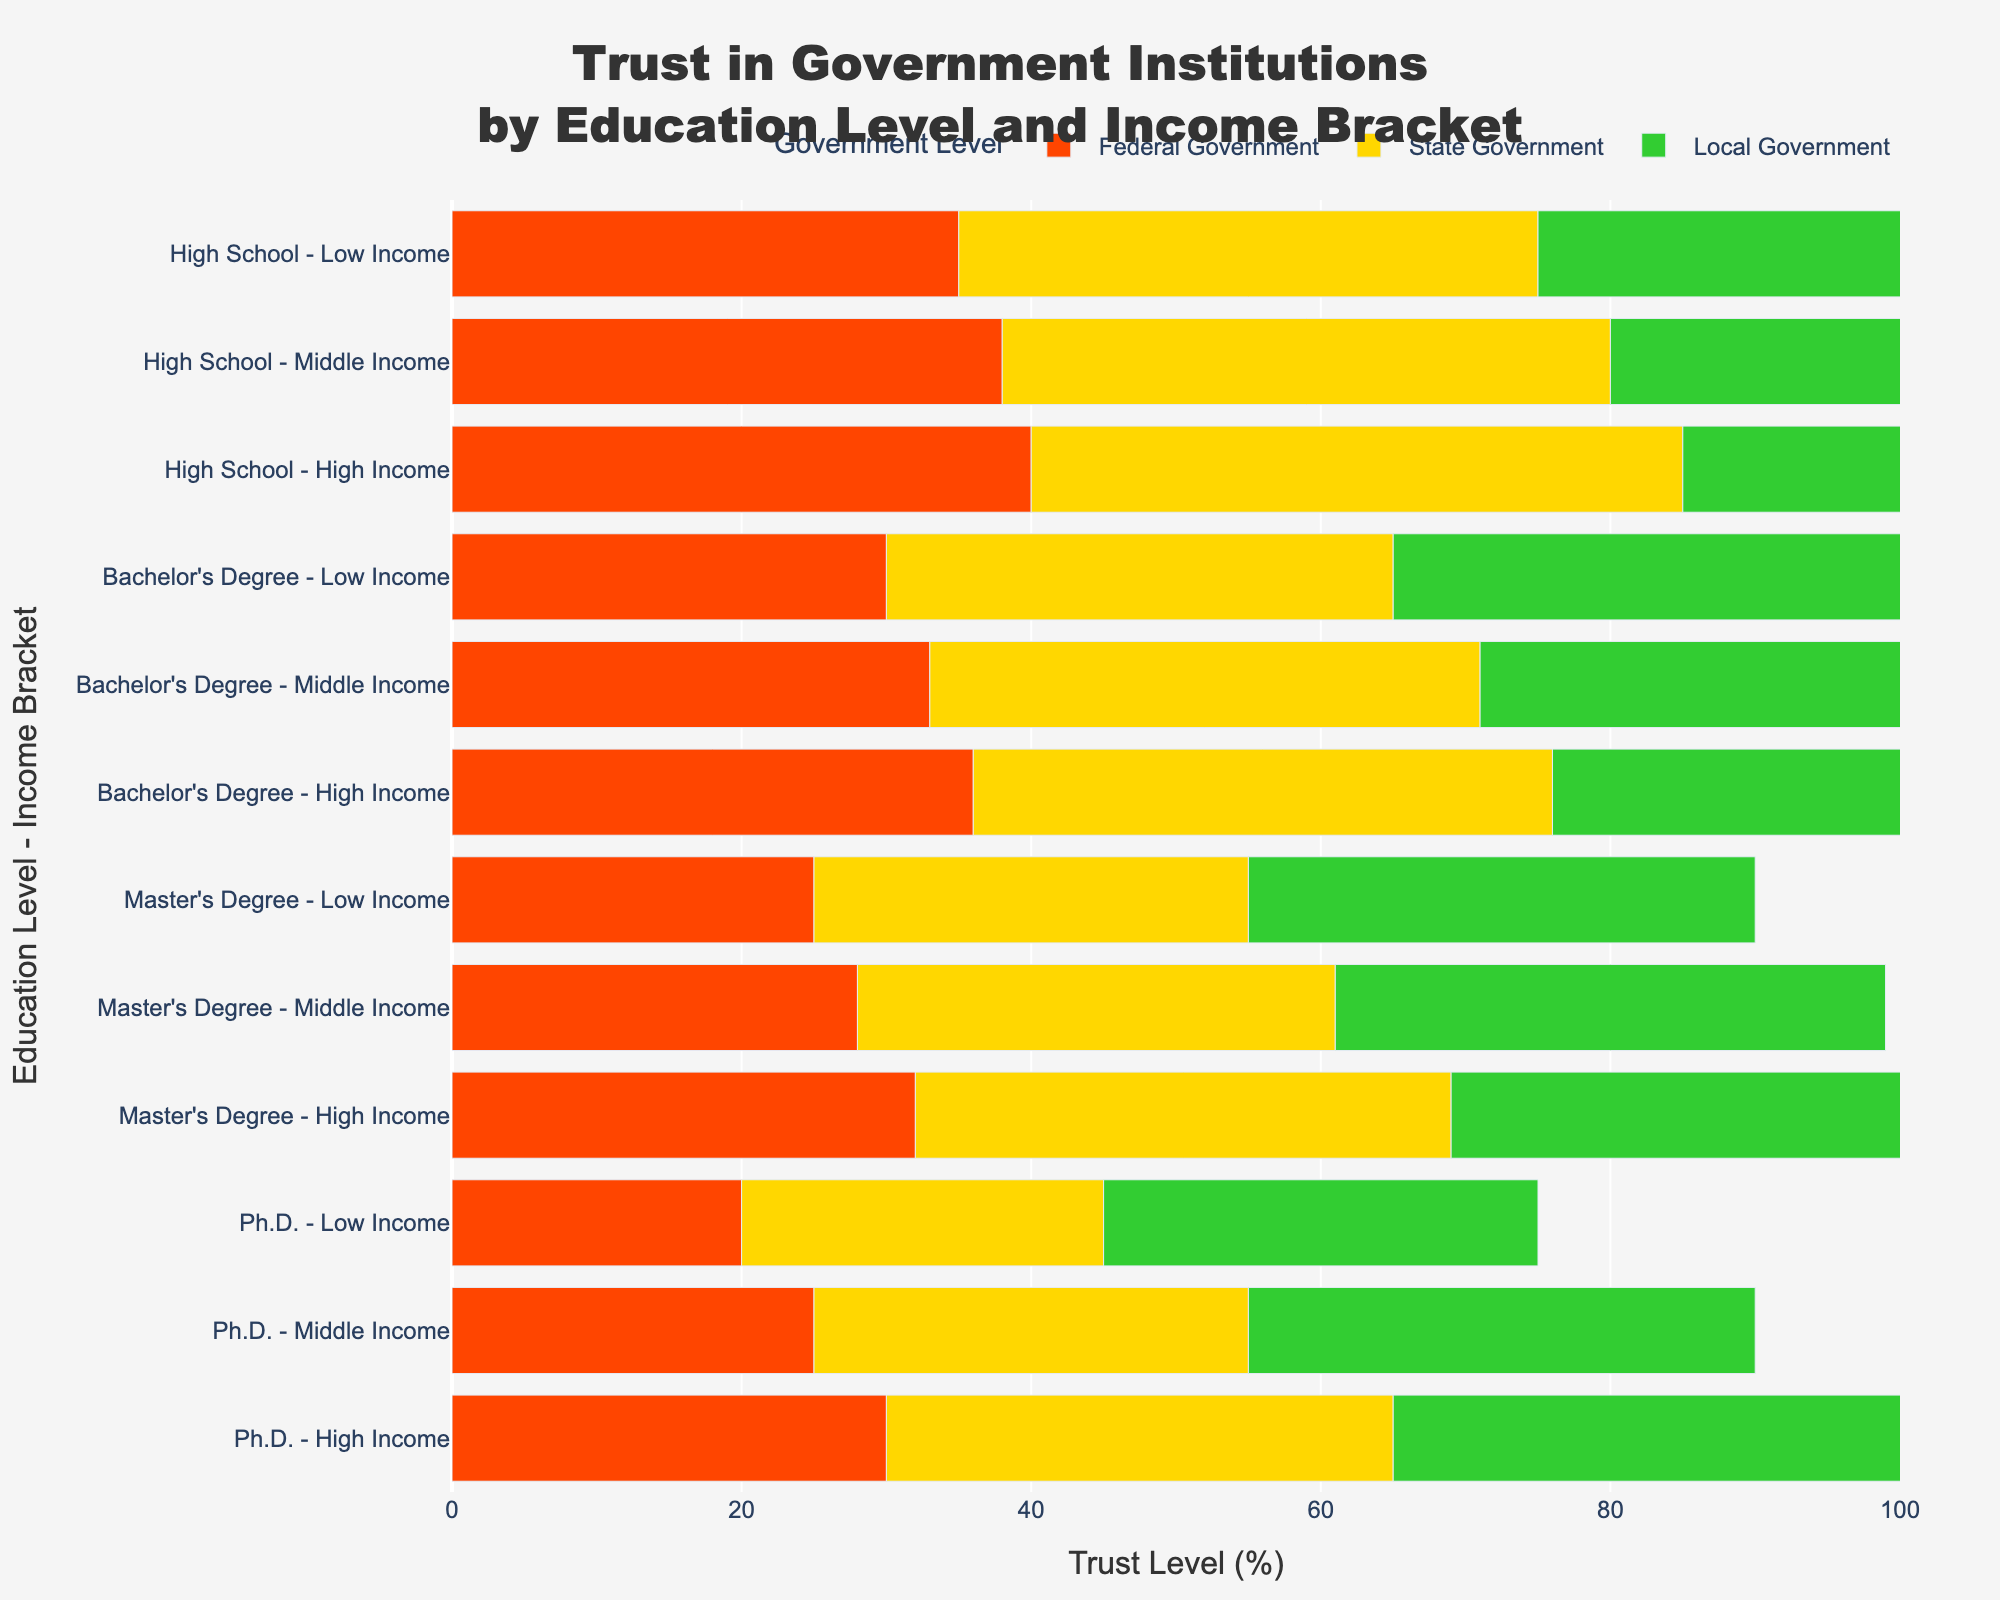What's the trust level in local government for those with a Bachelor's degree and high income? Look at the bar representing "Bachelor's Degree - High Income" and locate the segment for local government (usually the rightmost bar for that category). The trust level is directly shown around 45%.
Answer: 45% Comparing Ph.D. holders in the low-income bracket to those in the high-income bracket, who has more trust in the federal government? Check the bars for "Ph.D. - Low Income" and "Ph.D. - High Income" focusing on the federal government segment (leftmost). The low-income bracket has 20% trust, while the high-income bracket has 30%.
Answer: High-income bracket What's the difference in trust in state government between Master's degree holders with middle and low incomes? Identify the bars for "Master's Degree - Middle Income" and "Master's Degree - Low Income". The difference is 33% (middle) - 30% (low) = 3%.
Answer: 3% Which education level and income bracket has the highest trust in federal government? Scan through all educational levels and income brackets, focusing solely on the federal government bars (leftmost). The highest value is 40%, found in "High School - High Income".
Answer: High School - High Income On average, what's the trust level in local government across all income brackets for those with a Bachelor's degree? Add the trust levels for local government for Bachelor's degree: 40% (low) + 43% (middle) + 45% (high). Sum = 40+43+45 = 128. Dividing by the number of brackets (3), the average is 42.67%.
Answer: 42.67% How does trust in state government for high-income Master's degree holders compare to high-income Bachelor's degree holders? Compare the state government segment for "Master's Degree - High Income" (37%) with "Bachelor's Degree - High Income" (40%). The Master's degree holders have less trust.
Answer: Less Which group has the least trust in local government? Scan the rightmost segments for the smallest value. The "Ph.D. - Low Income" group has the least trust at 30%.
Answer: Ph.D. - Low Income How many percentage points difference is there between the highest and lowest trust in state government across all educational levels and income brackets? Identify the highest and lowest points in the state government segment. The highest is 45% (High School - High Income), and the lowest is 25% (Ph.D. - Low Income). Difference = 45 - 25 = 20%.
Answer: 20% What is the total trust (sum) in all government institutions for low-income Bachelor's degree holders? Add the trust levels for federal (30%), state (35%), and local government (40%). Total trust = 30 + 35 + 40 = 105%.
Answer: 105% For those with a Master's degree, what is the general trend in trust levels as income increases? Examine the bars for "Master's Degree", noting changes in trust levels for federal, state, and local governments. Generally, trust increases across all government levels as income rises from low to high.
Answer: Increasing How much more trust in local government do high-income individuals with a High School diploma have compared to middle-income individuals with the same education level? Compare trust in local government for "High School - High Income" (50%) and "High School - Middle Income" (47%). The difference is 50% - 47% = 3%.
Answer: 3% Does any group have equal trust in both state and local government? Compare the state and local government trust levels across all groups. No group shows equal trust percentages between state and local government.
Answer: No 